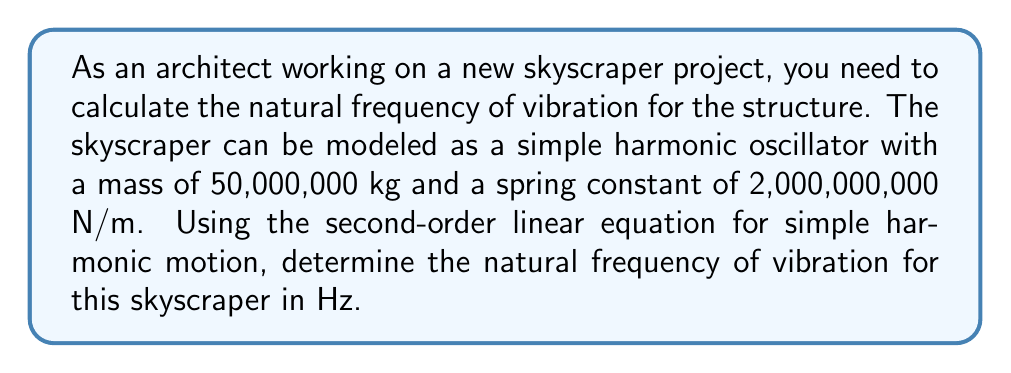Can you answer this question? To solve this problem, we'll use the following steps:

1. Recall the second-order linear equation for simple harmonic motion:

   $$m\frac{d^2x}{dt^2} + kx = 0$$

   where $m$ is the mass, $k$ is the spring constant, and $x$ is the displacement.

2. The natural angular frequency $\omega$ is given by:

   $$\omega = \sqrt{\frac{k}{m}}$$

3. Substitute the given values:
   $m = 50,000,000 \text{ kg}$
   $k = 2,000,000,000 \text{ N/m}$

   $$\omega = \sqrt{\frac{2,000,000,000}{50,000,000}}$$

4. Simplify:

   $$\omega = \sqrt{40} = 6.32455532 \text{ rad/s}$$

5. Convert angular frequency to frequency in Hz:

   $$f = \frac{\omega}{2\pi}$$

6. Calculate the final result:

   $$f = \frac{6.32455532}{2\pi} = 1.00636 \text{ Hz}$$
Answer: The natural frequency of vibration for the skyscraper is approximately 1.01 Hz. 